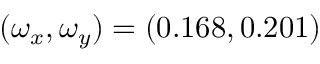<formula> <loc_0><loc_0><loc_500><loc_500>( \omega _ { x } , \omega _ { y } ) = ( 0 . 1 6 8 , 0 . 2 0 1 )</formula> 